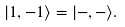<formula> <loc_0><loc_0><loc_500><loc_500>| 1 , - 1 \rangle = | - , - \rangle .</formula> 